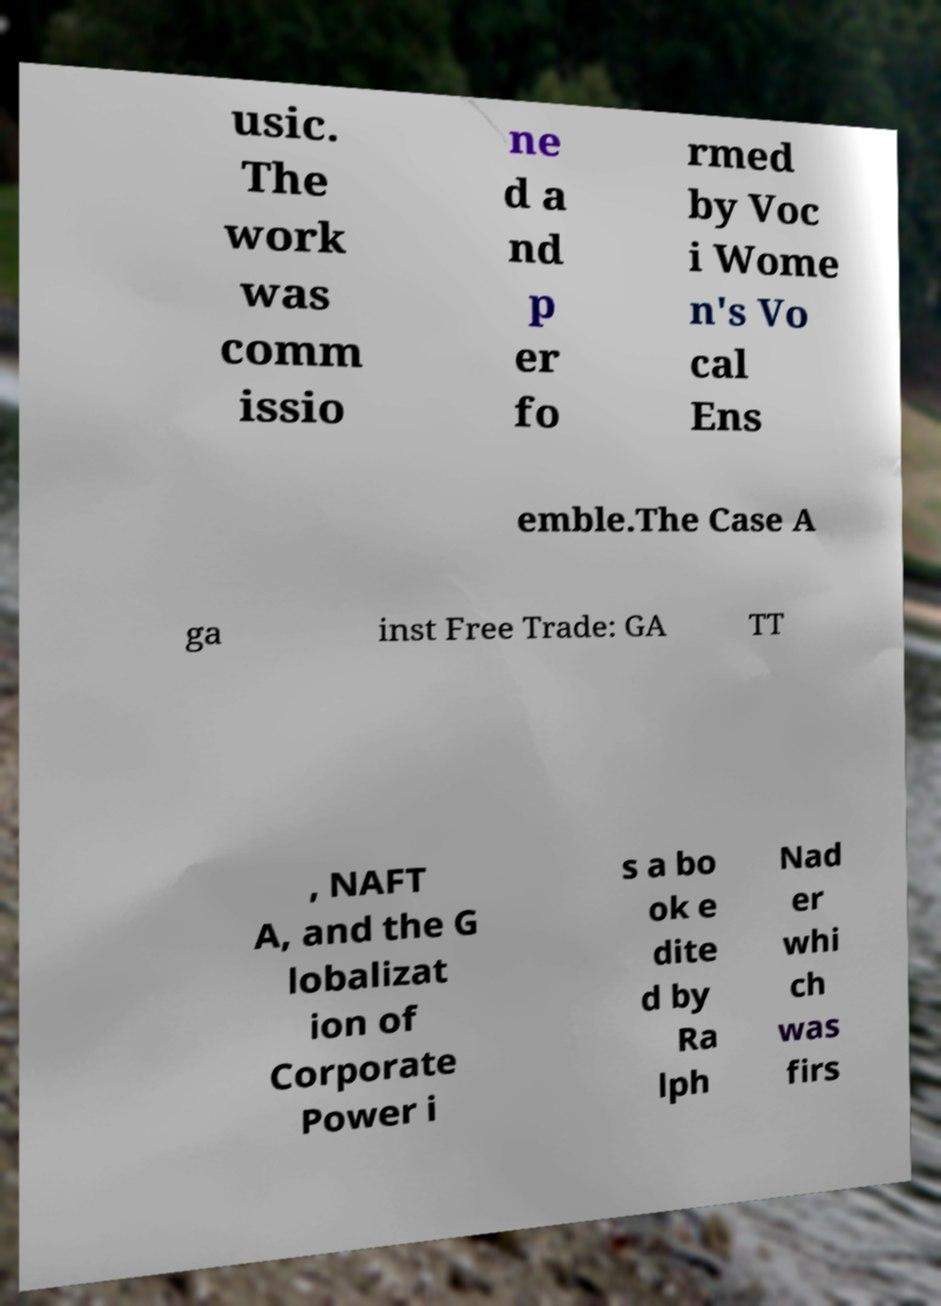Please read and relay the text visible in this image. What does it say? usic. The work was comm issio ne d a nd p er fo rmed by Voc i Wome n's Vo cal Ens emble.The Case A ga inst Free Trade: GA TT , NAFT A, and the G lobalizat ion of Corporate Power i s a bo ok e dite d by Ra lph Nad er whi ch was firs 